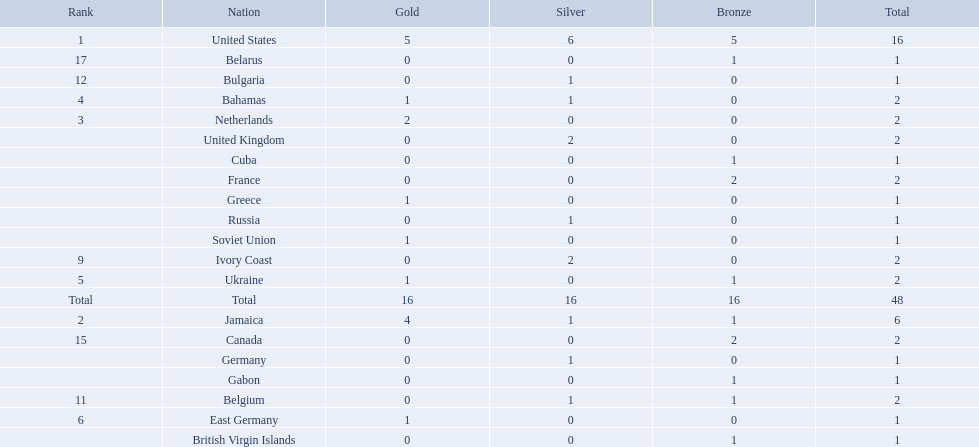What countries competed? United States, Jamaica, Netherlands, Bahamas, Ukraine, East Germany, Greece, Soviet Union, Ivory Coast, United Kingdom, Belgium, Bulgaria, Russia, Germany, Canada, France, Belarus, Cuba, Gabon, British Virgin Islands. Which countries won gold medals? United States, Jamaica, Netherlands, Bahamas, Ukraine, East Germany, Greece, Soviet Union. Which country had the second most medals? Jamaica. 